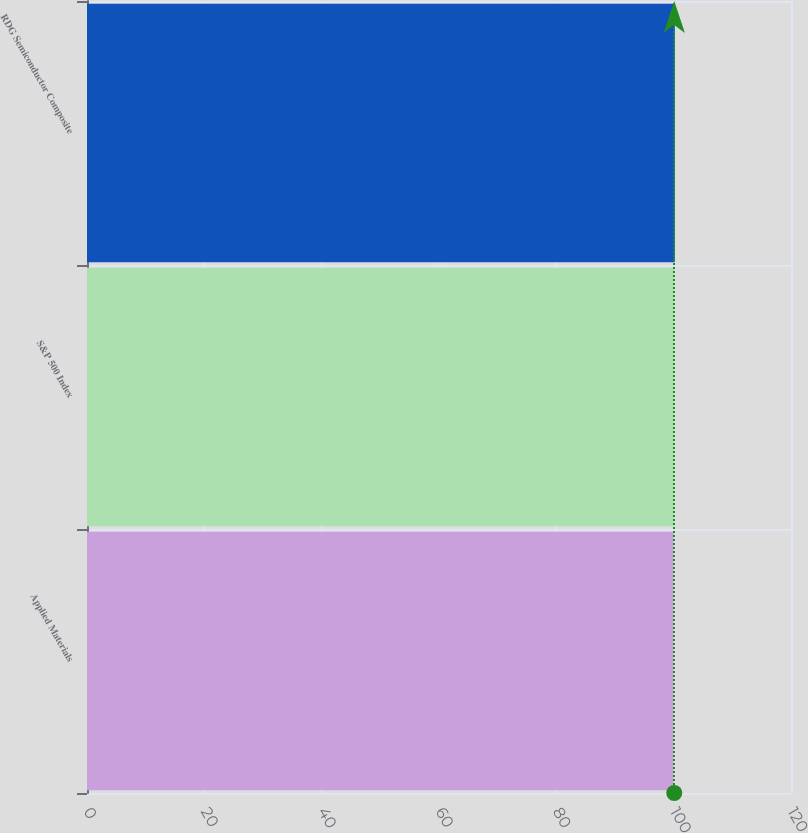Convert chart. <chart><loc_0><loc_0><loc_500><loc_500><bar_chart><fcel>Applied Materials<fcel>S&P 500 Index<fcel>RDG Semiconductor Composite<nl><fcel>100<fcel>100.1<fcel>100.2<nl></chart> 